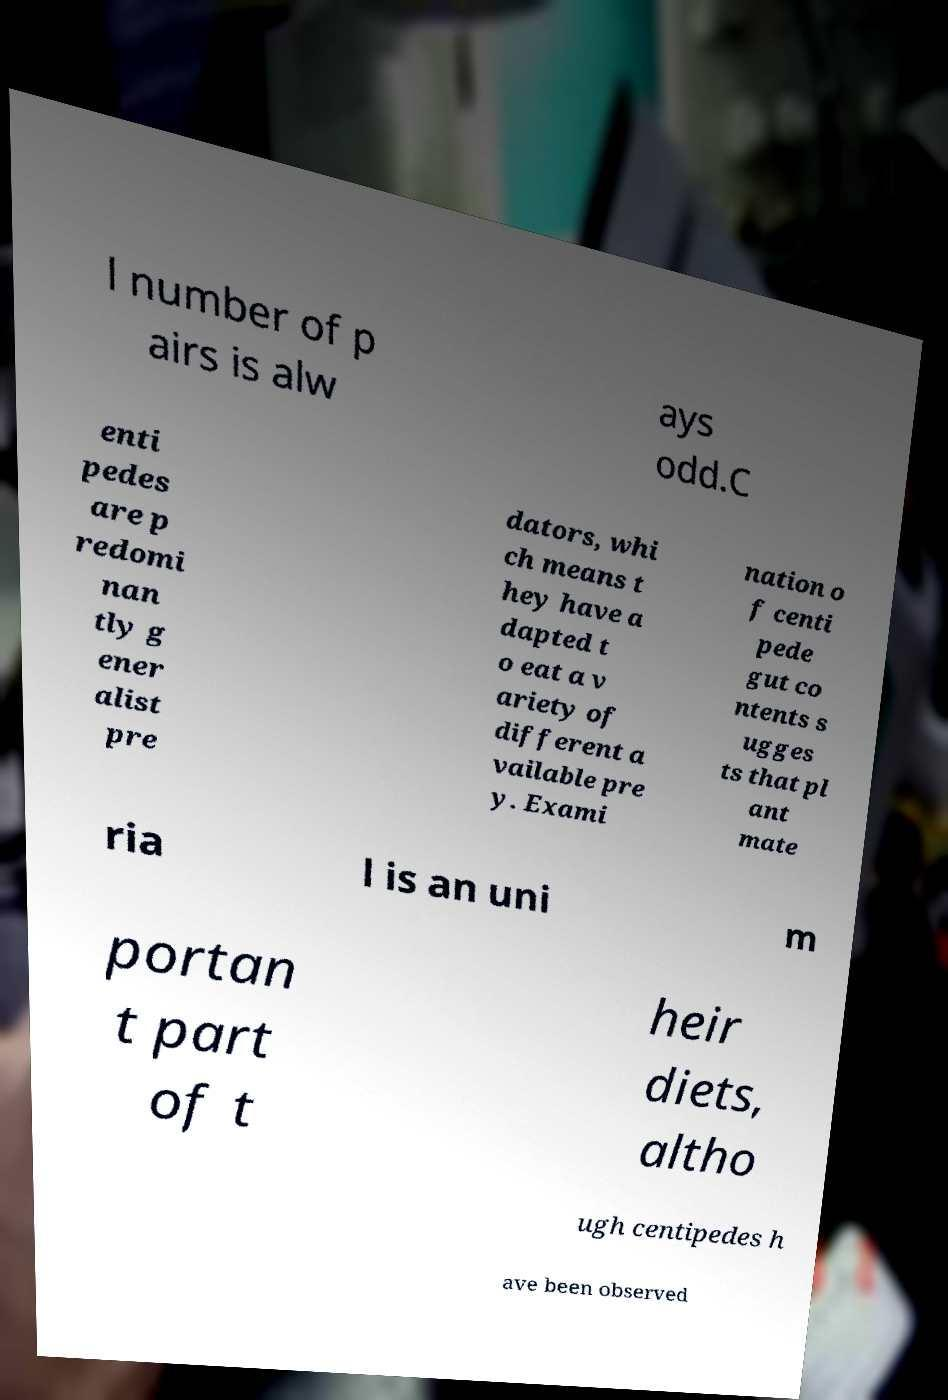Can you accurately transcribe the text from the provided image for me? l number of p airs is alw ays odd.C enti pedes are p redomi nan tly g ener alist pre dators, whi ch means t hey have a dapted t o eat a v ariety of different a vailable pre y. Exami nation o f centi pede gut co ntents s ugges ts that pl ant mate ria l is an uni m portan t part of t heir diets, altho ugh centipedes h ave been observed 